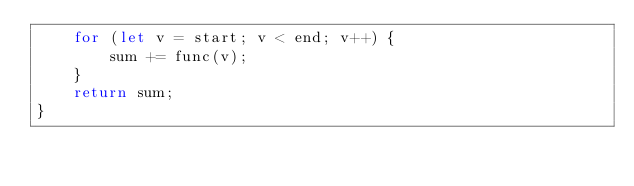Convert code to text. <code><loc_0><loc_0><loc_500><loc_500><_TypeScript_>    for (let v = start; v < end; v++) {
        sum += func(v);
    }
    return sum;
}</code> 